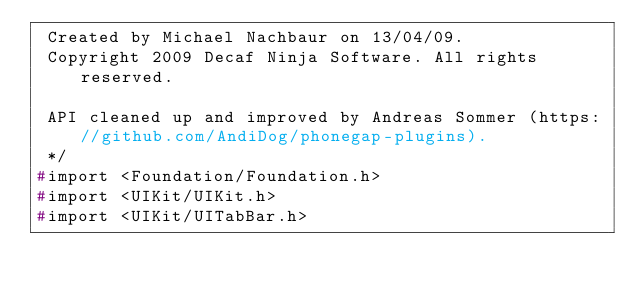Convert code to text. <code><loc_0><loc_0><loc_500><loc_500><_C_> Created by Michael Nachbaur on 13/04/09.
 Copyright 2009 Decaf Ninja Software. All rights reserved.

 API cleaned up and improved by Andreas Sommer (https://github.com/AndiDog/phonegap-plugins).
 */
#import <Foundation/Foundation.h>
#import <UIKit/UIKit.h>
#import <UIKit/UITabBar.h></code> 